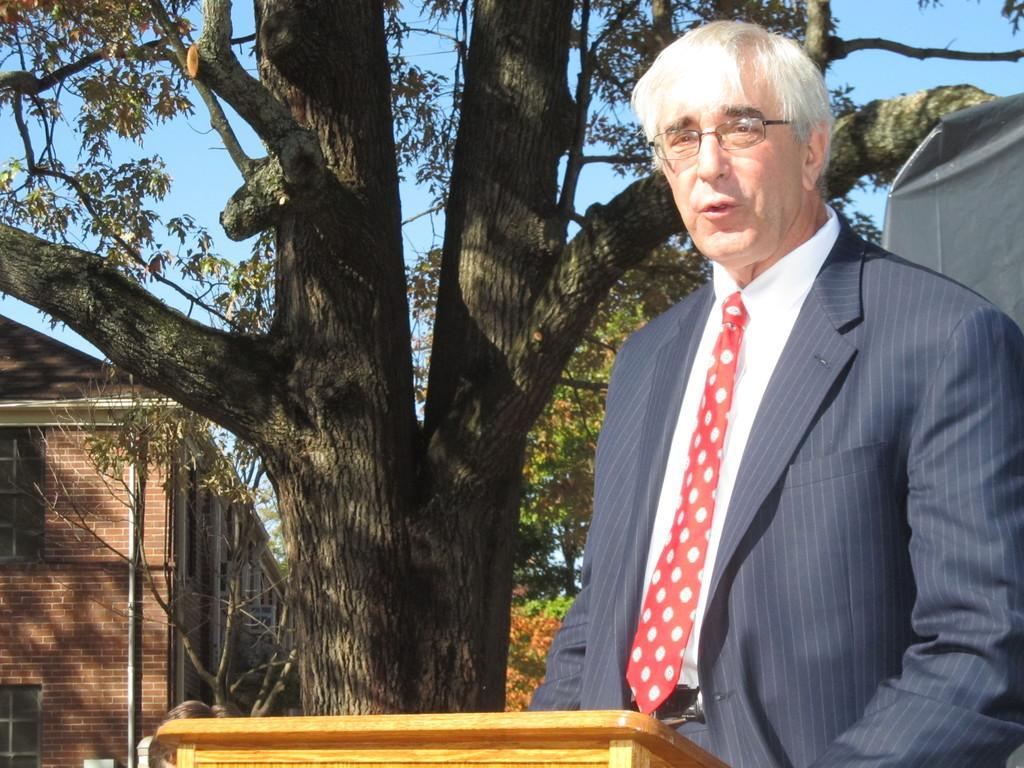Please provide a concise description of this image. In this image we can see a person and a wooden texture. In the background of the image there are some buildings, poles, trees and the sky. 